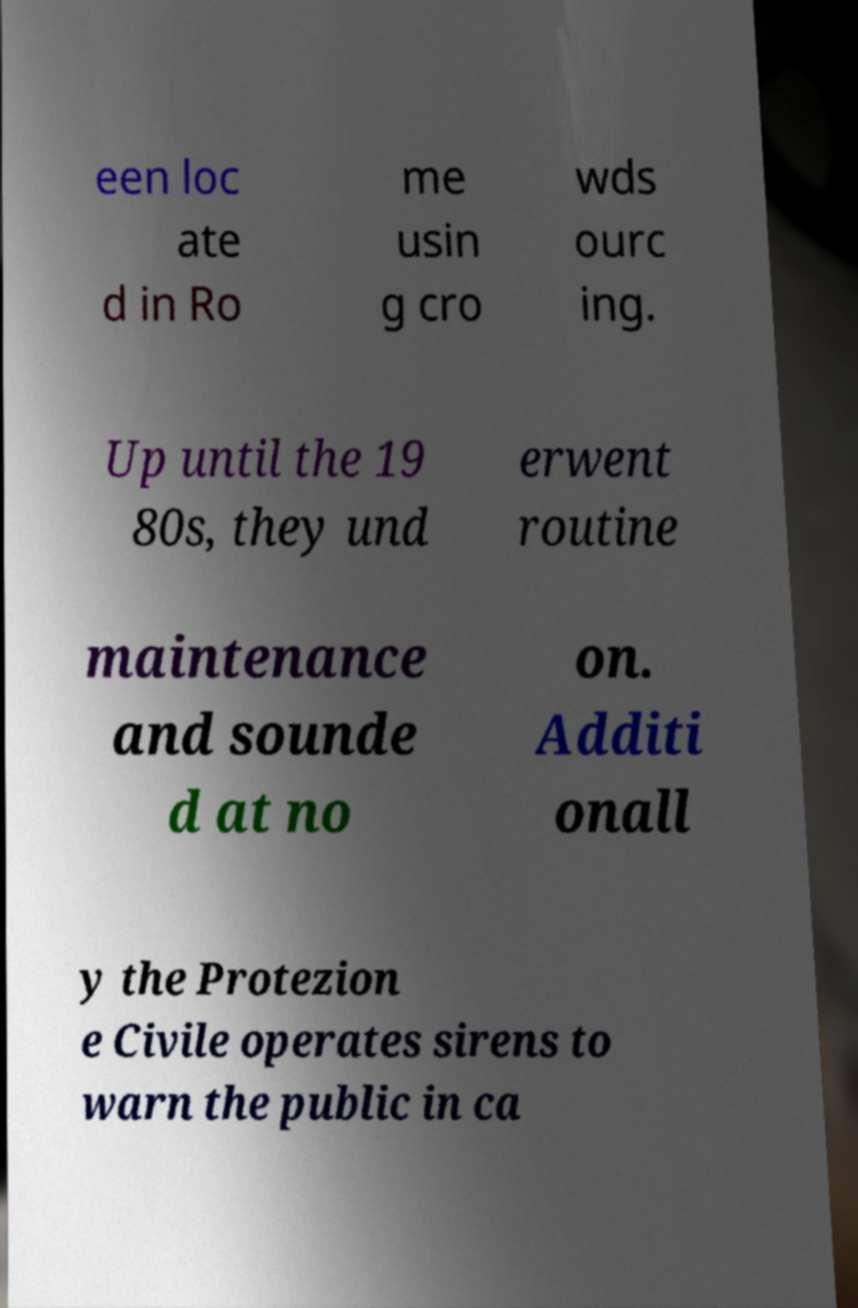There's text embedded in this image that I need extracted. Can you transcribe it verbatim? een loc ate d in Ro me usin g cro wds ourc ing. Up until the 19 80s, they und erwent routine maintenance and sounde d at no on. Additi onall y the Protezion e Civile operates sirens to warn the public in ca 